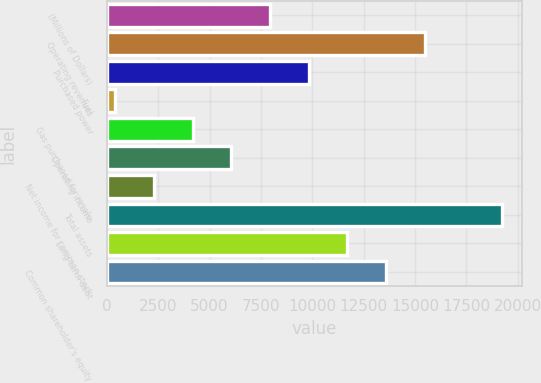<chart> <loc_0><loc_0><loc_500><loc_500><bar_chart><fcel>(Millions of Dollars)<fcel>Operating revenues<fcel>Purchased power<fcel>Fuel<fcel>Gas purchased for resale<fcel>Operating income<fcel>Net income for common stock<fcel>Total assets<fcel>Long-term debt<fcel>Common shareholder's equity<nl><fcel>7940<fcel>15476<fcel>9824<fcel>404<fcel>4172<fcel>6056<fcel>2288<fcel>19244<fcel>11708<fcel>13592<nl></chart> 